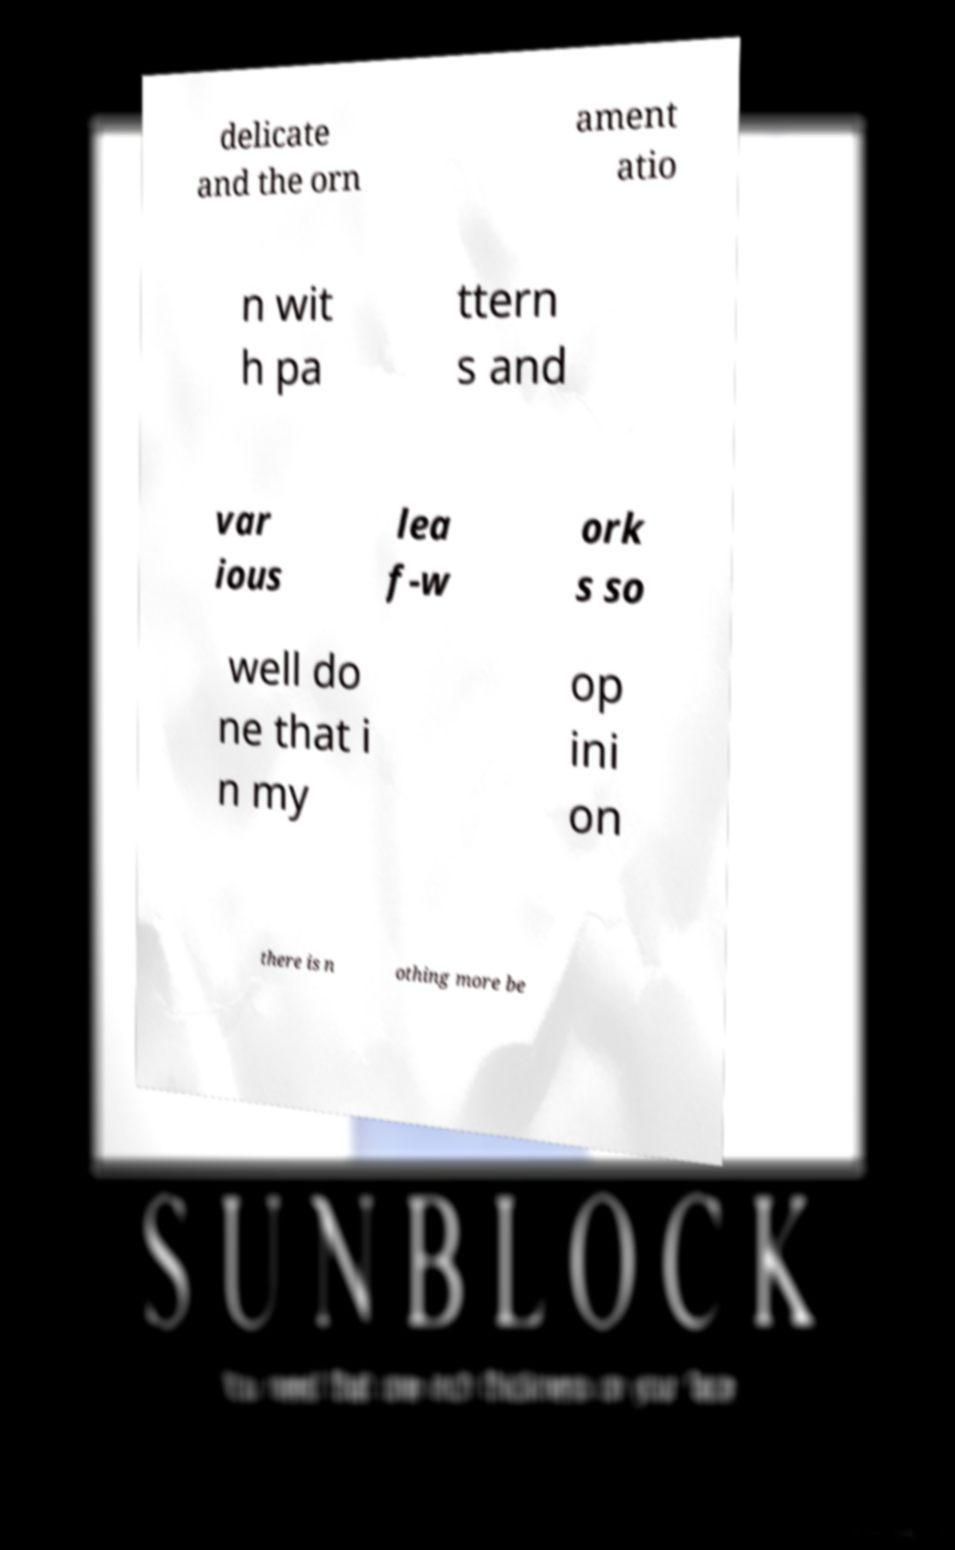What messages or text are displayed in this image? I need them in a readable, typed format. delicate and the orn ament atio n wit h pa ttern s and var ious lea f-w ork s so well do ne that i n my op ini on there is n othing more be 